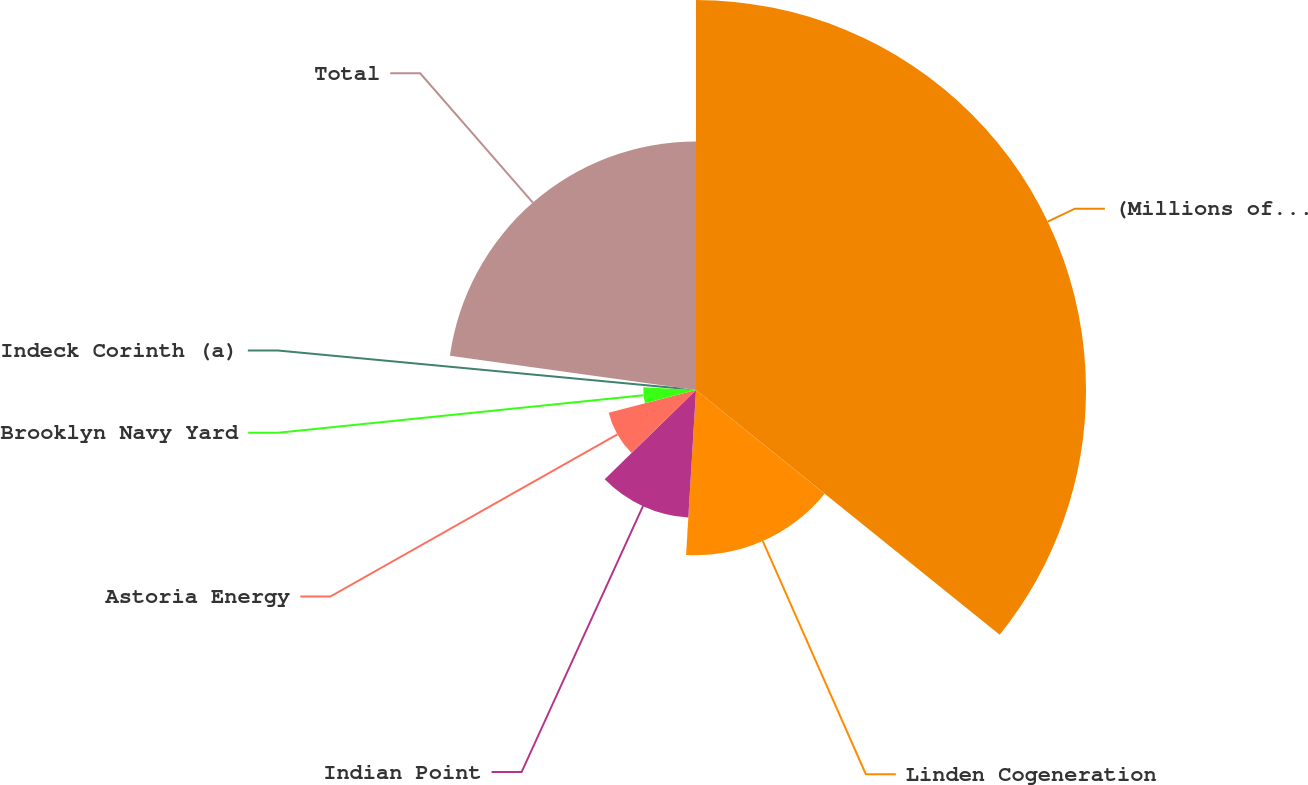Convert chart. <chart><loc_0><loc_0><loc_500><loc_500><pie_chart><fcel>(Millions of Dollars)<fcel>Linden Cogeneration<fcel>Indian Point<fcel>Astoria Energy<fcel>Brooklyn Navy Yard<fcel>Indeck Corinth (a)<fcel>Total<nl><fcel>35.79%<fcel>15.16%<fcel>11.72%<fcel>8.28%<fcel>4.84%<fcel>1.4%<fcel>22.8%<nl></chart> 